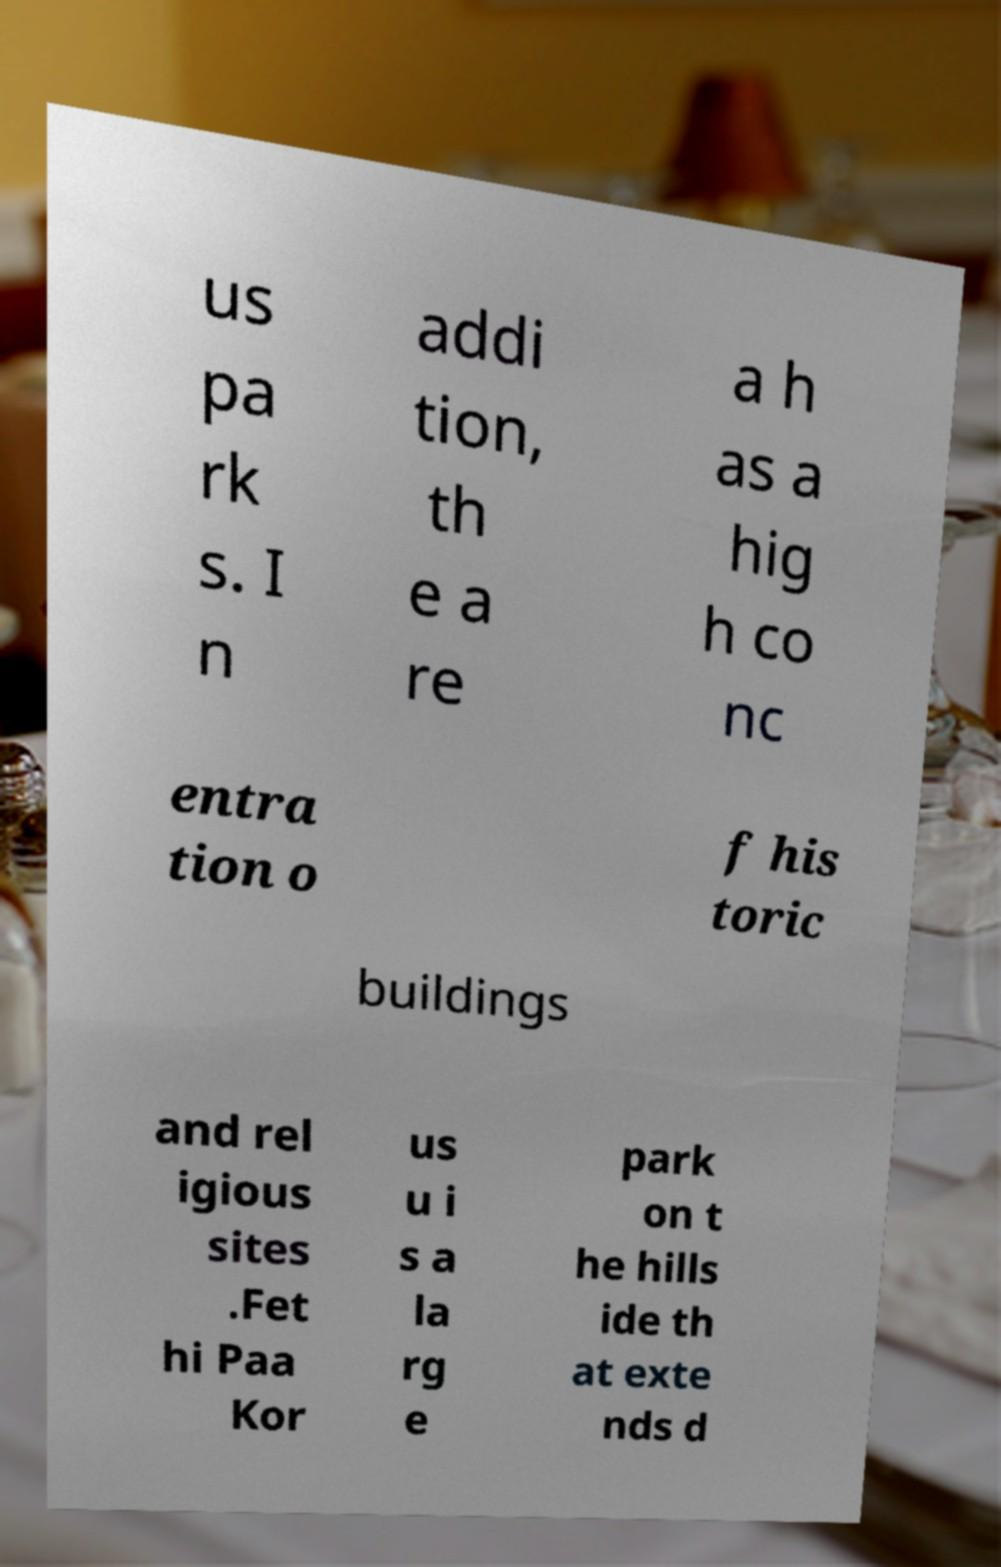There's text embedded in this image that I need extracted. Can you transcribe it verbatim? us pa rk s. I n addi tion, th e a re a h as a hig h co nc entra tion o f his toric buildings and rel igious sites .Fet hi Paa Kor us u i s a la rg e park on t he hills ide th at exte nds d 